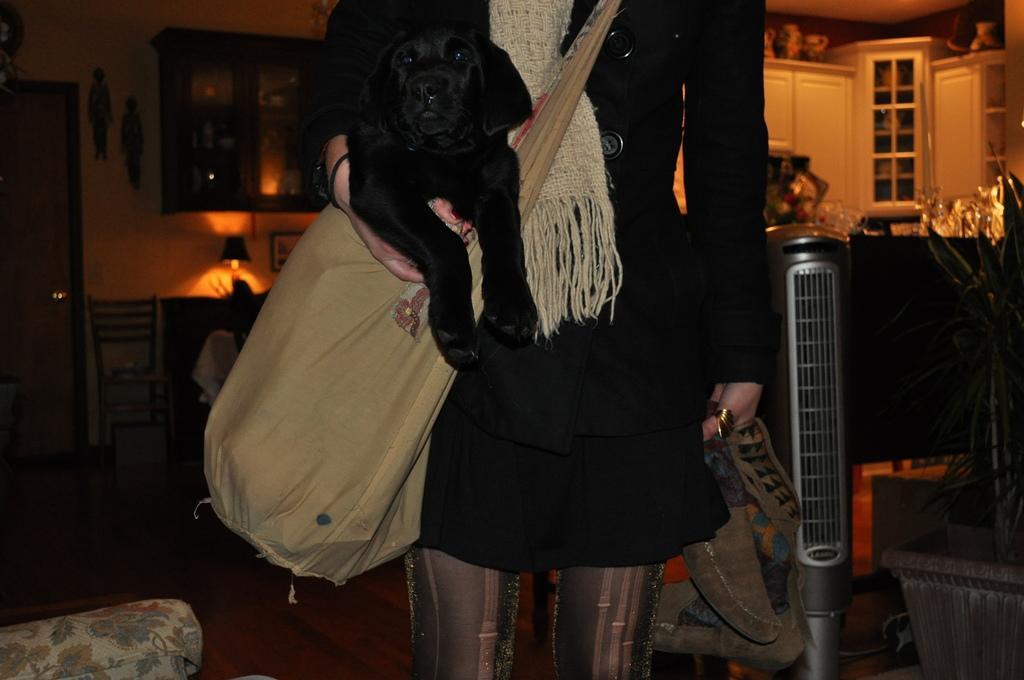In one or two sentences, can you explain what this image depicts? The woman in front of the picture wearing a black dress, scarf and a bag is standing and she is holding the shoes in her hands. Behind her, we see a table on which lamp is placed. Beside that, we see a cupboard. On the left side, we see a door. On the right side, we see a table and cupboards in white color. This picture is clicked inside the room. 